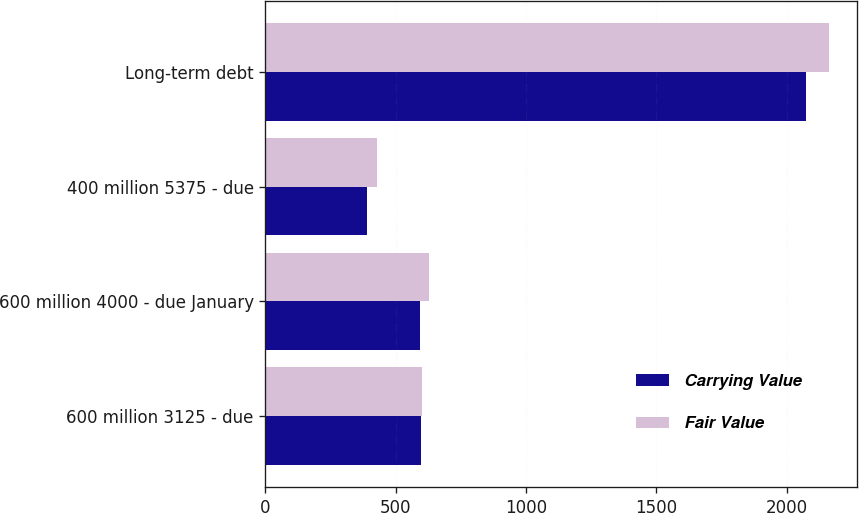Convert chart to OTSL. <chart><loc_0><loc_0><loc_500><loc_500><stacked_bar_chart><ecel><fcel>600 million 3125 - due<fcel>600 million 4000 - due January<fcel>400 million 5375 - due<fcel>Long-term debt<nl><fcel>Carrying Value<fcel>596.1<fcel>592.7<fcel>389.8<fcel>2072.8<nl><fcel>Fair Value<fcel>601.4<fcel>628.3<fcel>428.6<fcel>2161.3<nl></chart> 